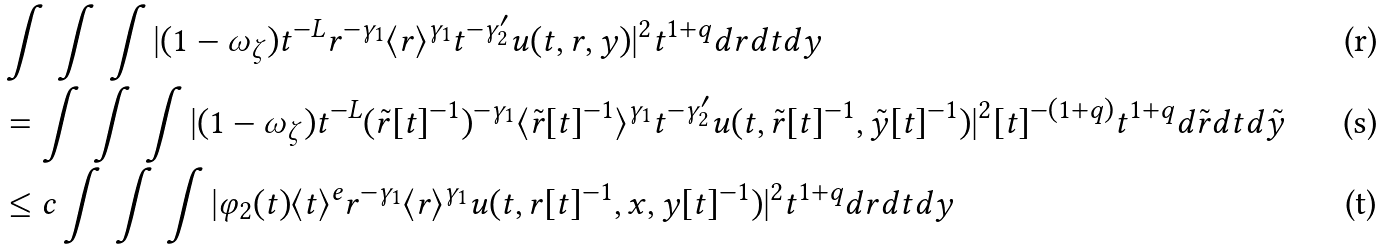Convert formula to latex. <formula><loc_0><loc_0><loc_500><loc_500>& \int \, \int \, \int | ( 1 - \omega _ { \zeta } ) t ^ { - L } r ^ { - \gamma _ { 1 } } \langle r \rangle ^ { \gamma _ { 1 } } t ^ { - \gamma ^ { \prime } _ { 2 } } u ( t , r , y ) | ^ { 2 } t ^ { 1 + q } d r d t d y \\ & = \int \, \int \, \int | ( 1 - \omega _ { \zeta } ) t ^ { - L } ( \tilde { r } [ t ] ^ { - 1 } ) ^ { - \gamma _ { 1 } } \langle \tilde { r } [ t ] ^ { - 1 } \rangle ^ { \gamma _ { 1 } } t ^ { - \gamma ^ { \prime } _ { 2 } } u ( t , \tilde { r } [ t ] ^ { - 1 } , \tilde { y } [ t ] ^ { - 1 } ) | ^ { 2 } [ t ] ^ { - ( 1 + q ) } t ^ { 1 + q } d \tilde { r } d t d \tilde { y } \\ & \leq c \int \, \int \, \int | \varphi _ { 2 } ( t ) \langle t \rangle ^ { e } r ^ { - \gamma _ { 1 } } \langle r \rangle ^ { \gamma _ { 1 } } u ( t , r [ t ] ^ { - 1 } , x , y [ t ] ^ { - 1 } ) | ^ { 2 } t ^ { 1 + q } d r d t d y</formula> 